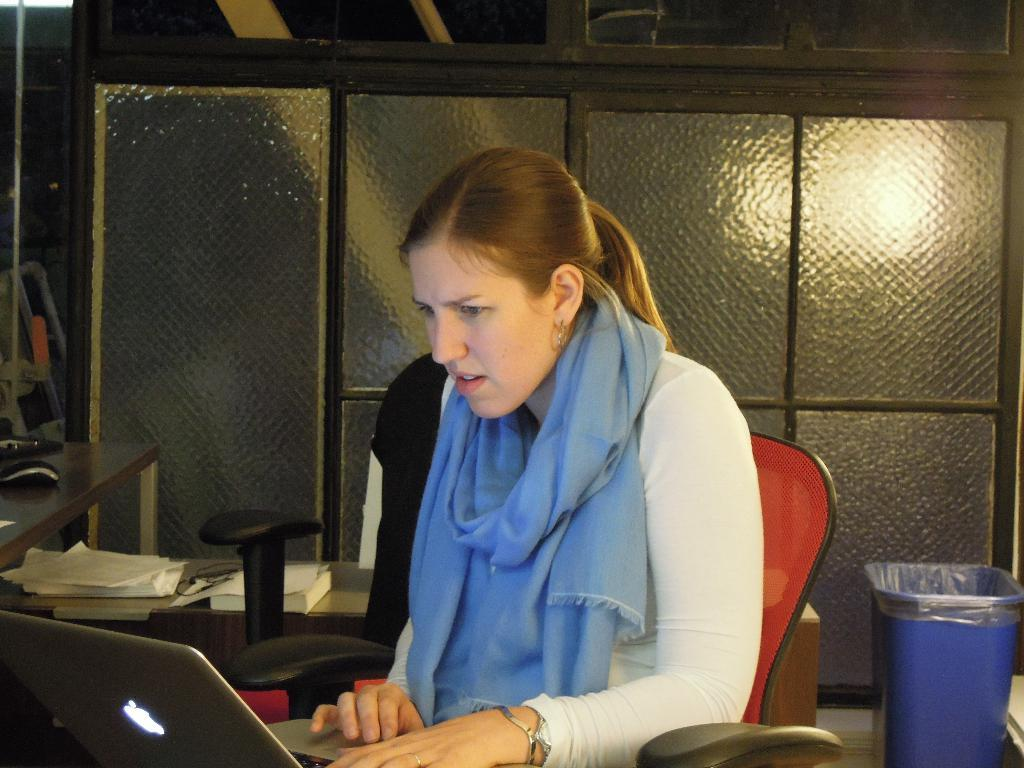What is the person in the image doing? The person is sitting on a chair and looking at a laptop. What can be seen in the background of the image? There is a cupboard and a dustbin in the background. Reasoning: Let' Let's think step by step in order to produce the conversation. We start by identifying the main subject in the image, which is the person sitting on a chair. Then, we describe what the person is doing, which is looking at a laptop. Finally, we expand the conversation to include other objects visible in the background, such as the cupboard and dustbin. Each question is designed to elicit a specific detail about the image that is known from the provided facts. Absurd Question/Answer: What type of jewel is the person wearing in the image? There is no mention of a jewel in the image, so we cannot determine if the person is wearing one. 